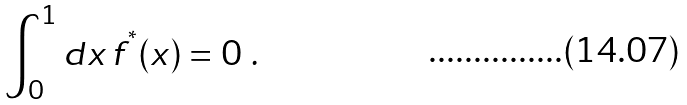<formula> <loc_0><loc_0><loc_500><loc_500>\int _ { 0 } ^ { 1 } d x \, f ^ { ^ { * } } ( x ) = 0 \ .</formula> 